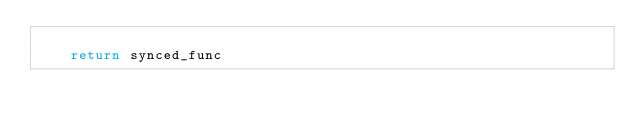Convert code to text. <code><loc_0><loc_0><loc_500><loc_500><_Python_>
    return synced_func
</code> 